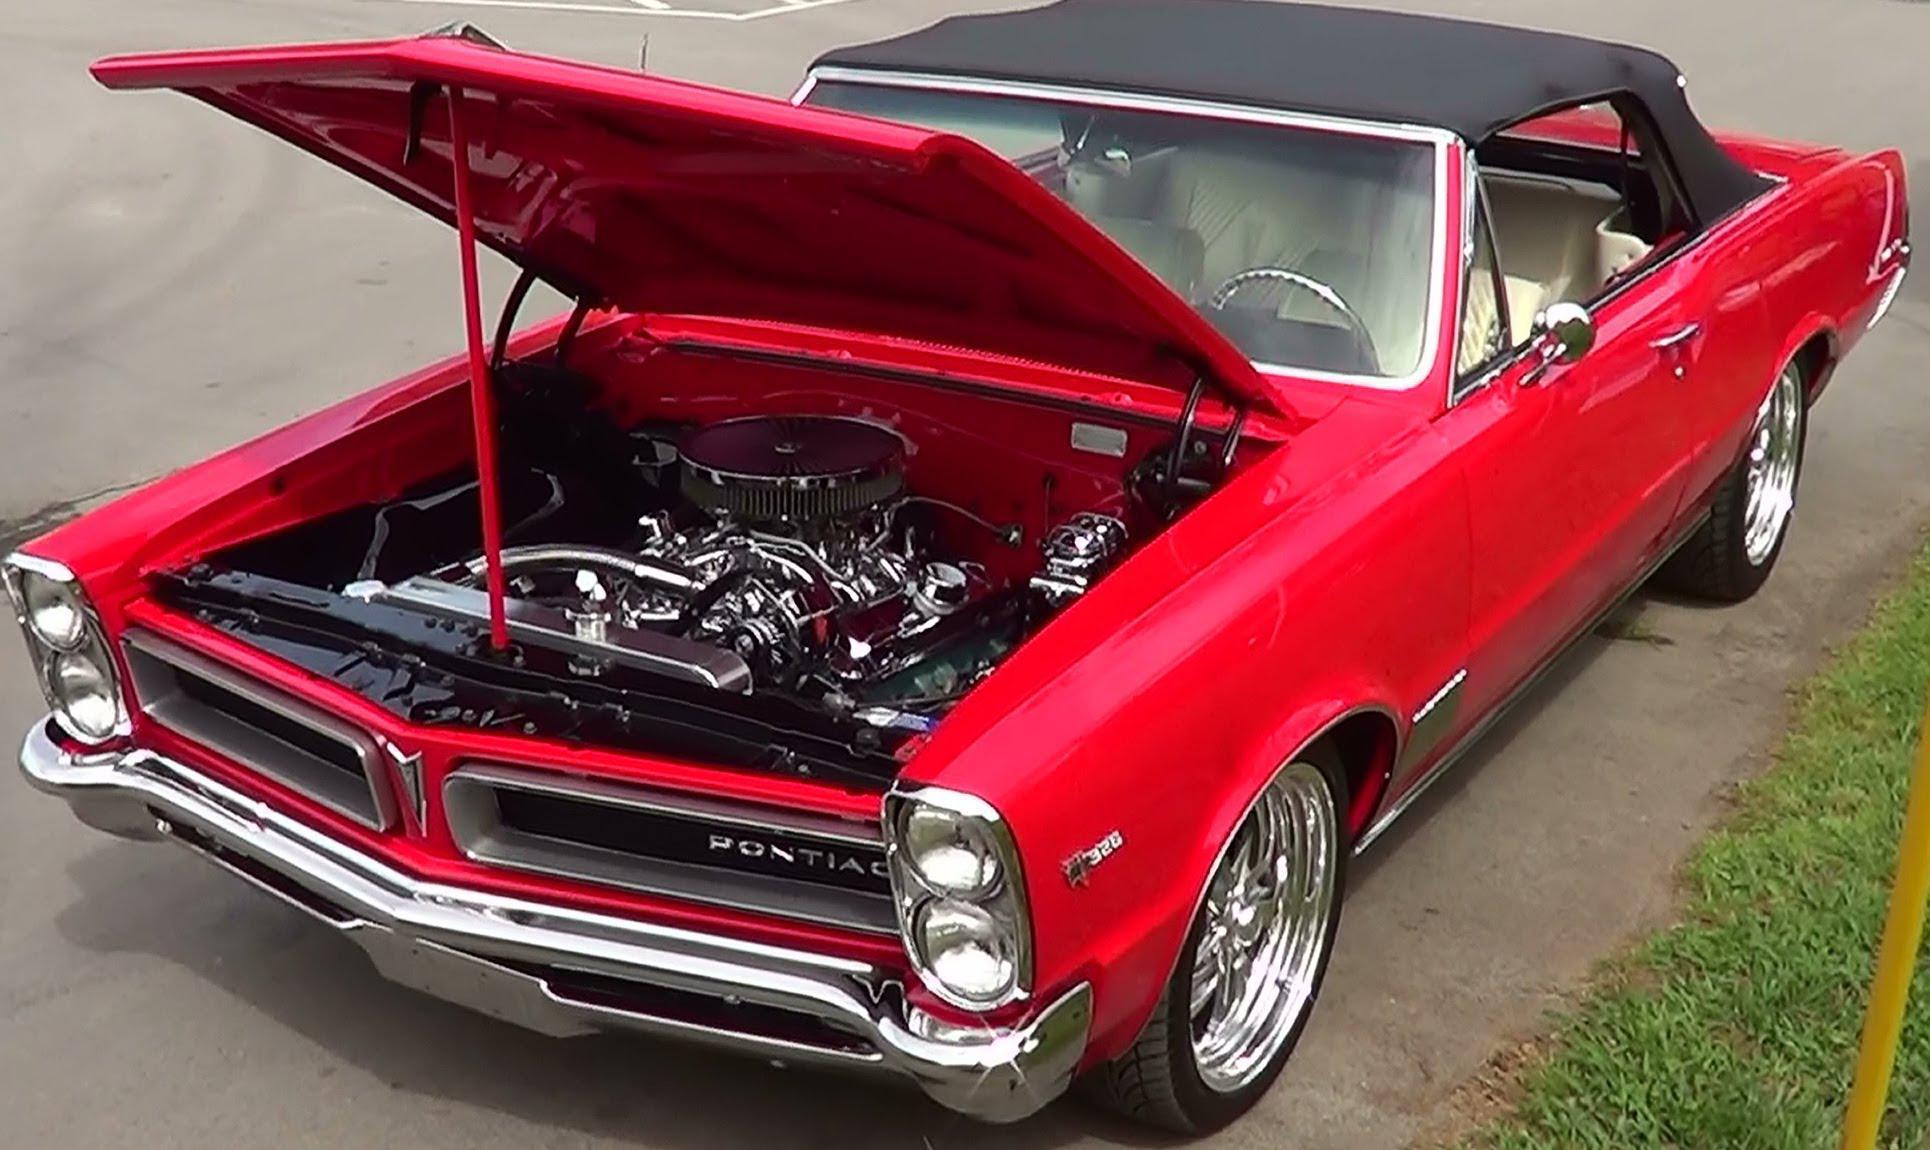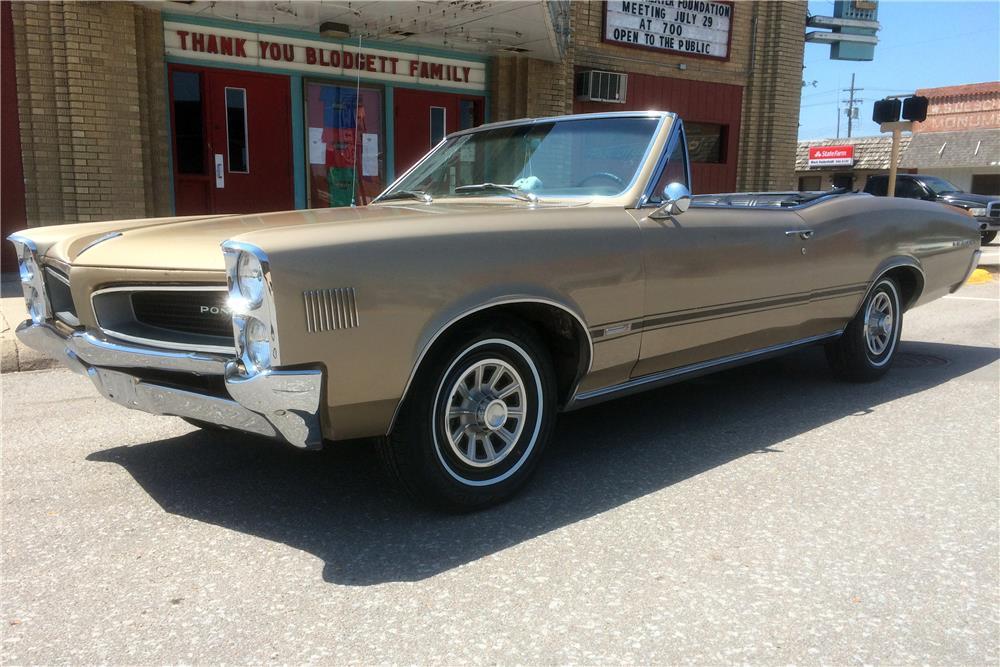The first image is the image on the left, the second image is the image on the right. Analyze the images presented: Is the assertion "At least one vehicle is not red or pink." valid? Answer yes or no. Yes. 